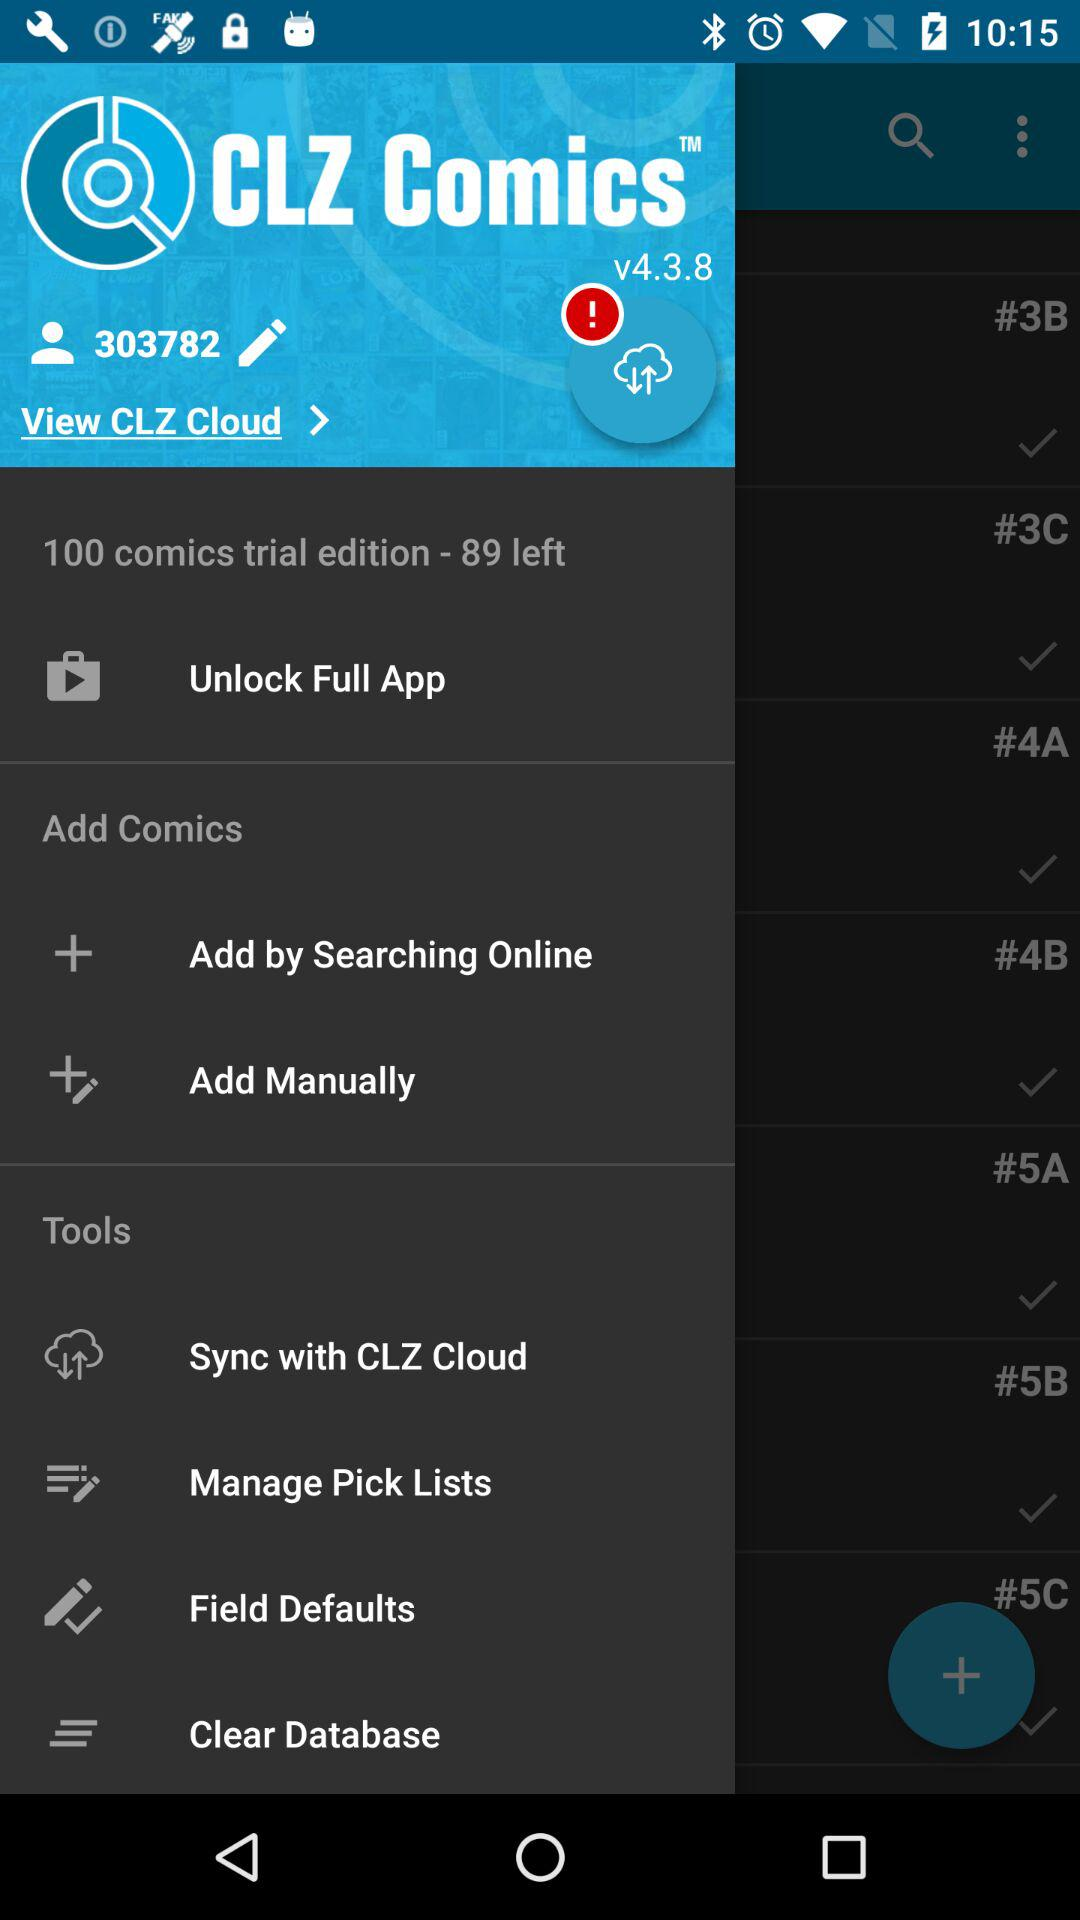How many comics in total are there in the trial edition? There are 100 comics. 